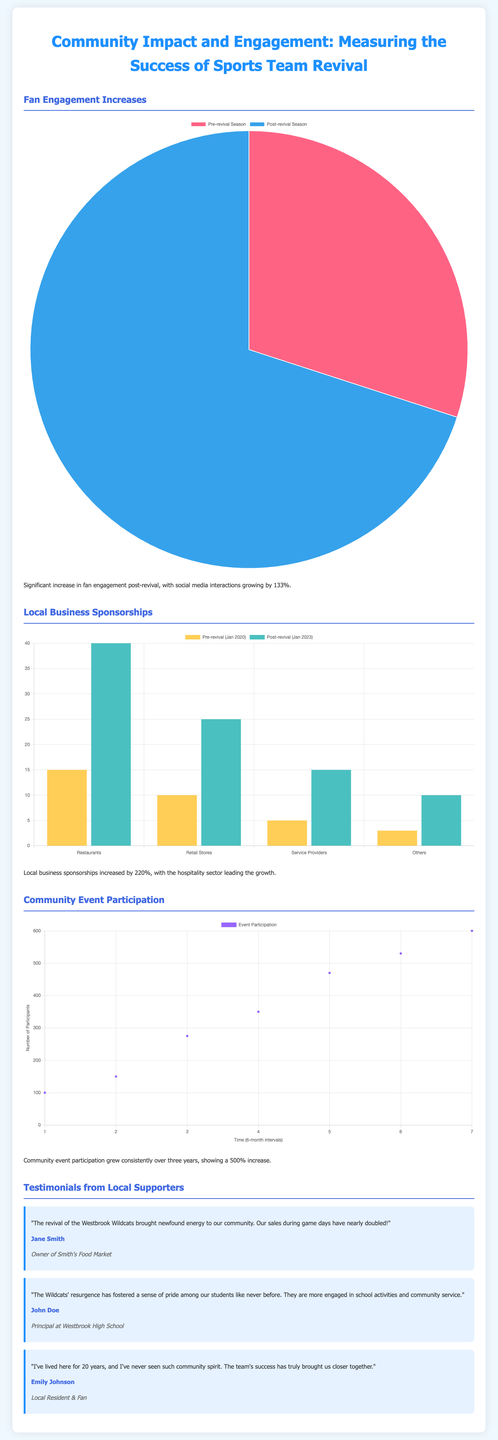What was the percentage increase in fan engagement post-revival? Fan engagement increased by 133% as stated in the document.
Answer: 133% What is the percentage increase in local business sponsorships? Local business sponsorships increased by 220% according to the infographic.
Answer: 220% How much did community event participation increase overall? The document mentions a consistent growth resulting in a 500% increase in event participation.
Answer: 500% Which sector led the growth in local business sponsorships? The hospitality sector is noted as leading the growth in local business sponsorships.
Answer: Hospitality sector Who is the author of the testimonial stating that game day sales nearly doubled? The testimonial from Jane Smith, owner of Smith's Food Market, mentions the sales increase during game days.
Answer: Jane Smith How many businesses were included in the local sponsorship bar chart before the revival? The bar chart included four categories of businesses before the revival, as indicated in the document.
Answer: Four What type of chart is used to depict community event participation? A scatter plot is utilized to represent the community event participation data in the infographic.
Answer: Scatter plot What is the x-axis label in the community event participation chart? The x-axis label is "Time (6-month intervals)" based on the chart specifications.
Answer: Time (6-month intervals) What were the two time periods compared in the local business sponsorships chart? The comparison is between Pre-revival (Jan 2020) and Post-revival (Jan 2023) in the sponsorship chart.
Answer: Pre-revival and Post-revival 